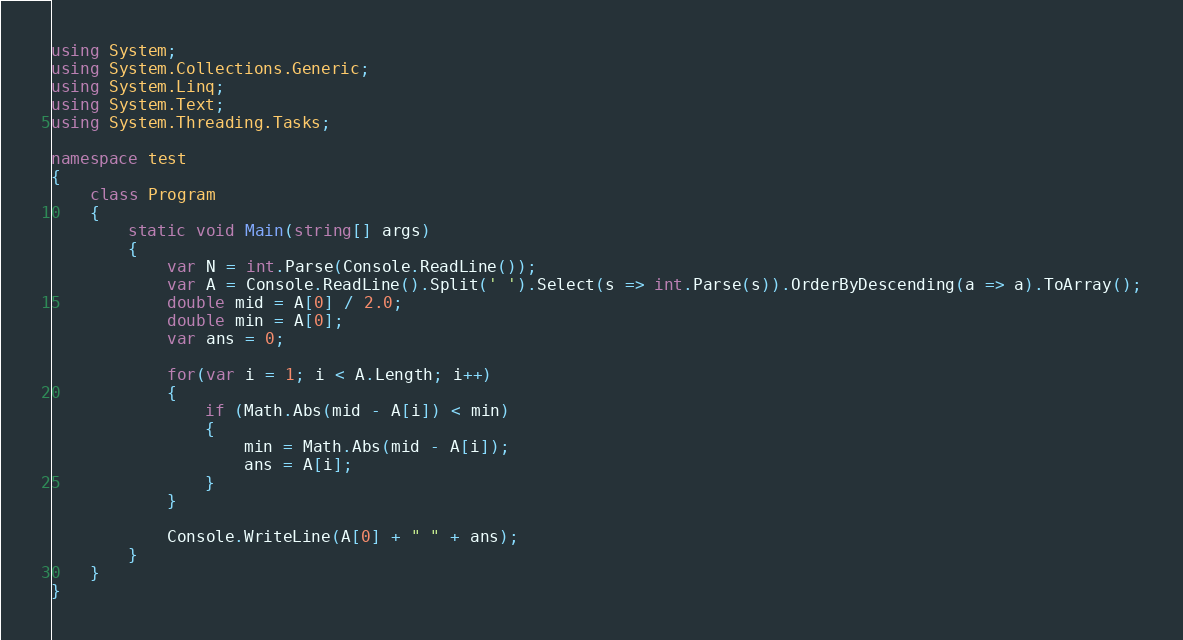Convert code to text. <code><loc_0><loc_0><loc_500><loc_500><_C#_>using System;
using System.Collections.Generic;
using System.Linq;
using System.Text;
using System.Threading.Tasks;

namespace test
{
    class Program
    {
        static void Main(string[] args)
        {
            var N = int.Parse(Console.ReadLine());
            var A = Console.ReadLine().Split(' ').Select(s => int.Parse(s)).OrderByDescending(a => a).ToArray();
            double mid = A[0] / 2.0;
            double min = A[0];
            var ans = 0;

            for(var i = 1; i < A.Length; i++)
            {
                if (Math.Abs(mid - A[i]) < min)
                {
                    min = Math.Abs(mid - A[i]);
                    ans = A[i];
                }
            }

            Console.WriteLine(A[0] + " " + ans);
        }
    }
}</code> 